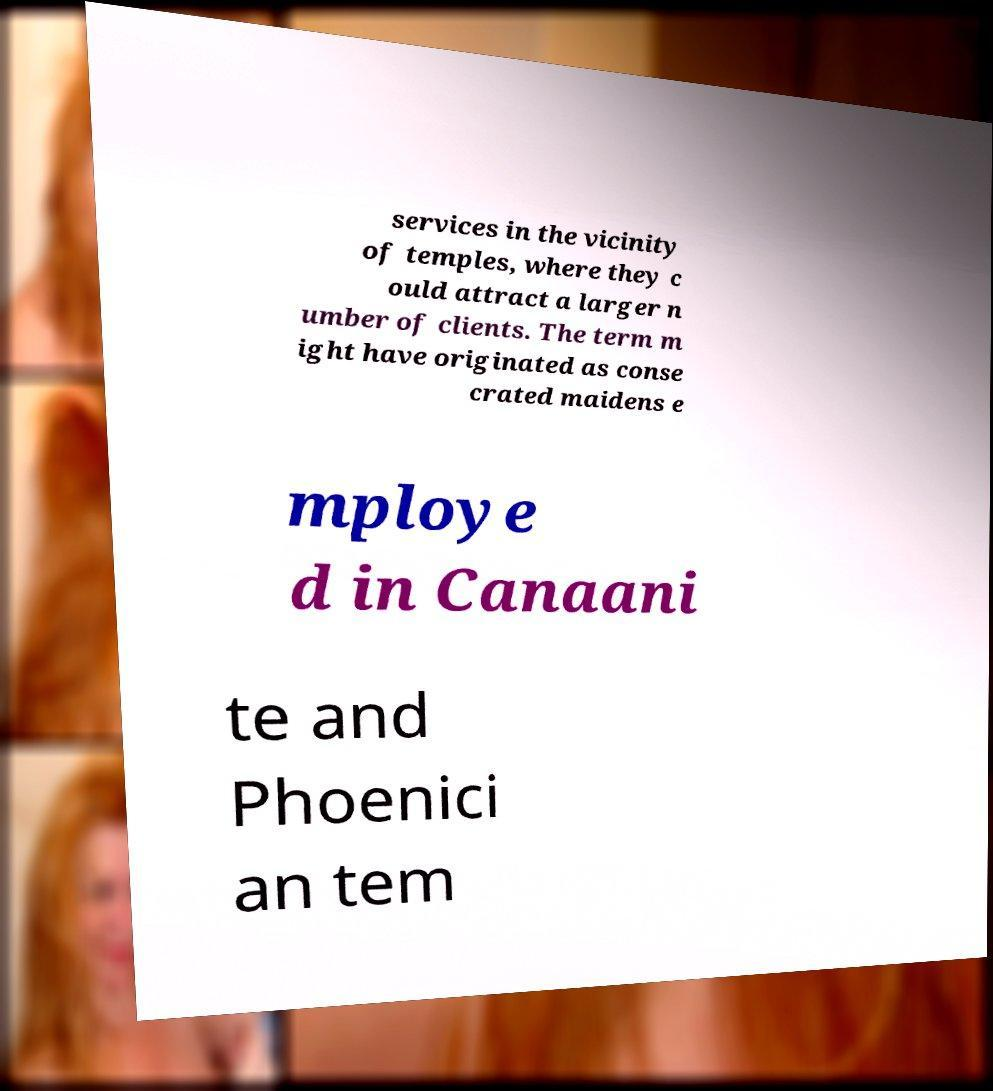For documentation purposes, I need the text within this image transcribed. Could you provide that? services in the vicinity of temples, where they c ould attract a larger n umber of clients. The term m ight have originated as conse crated maidens e mploye d in Canaani te and Phoenici an tem 